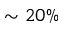<formula> <loc_0><loc_0><loc_500><loc_500>\sim 2 0 \%</formula> 